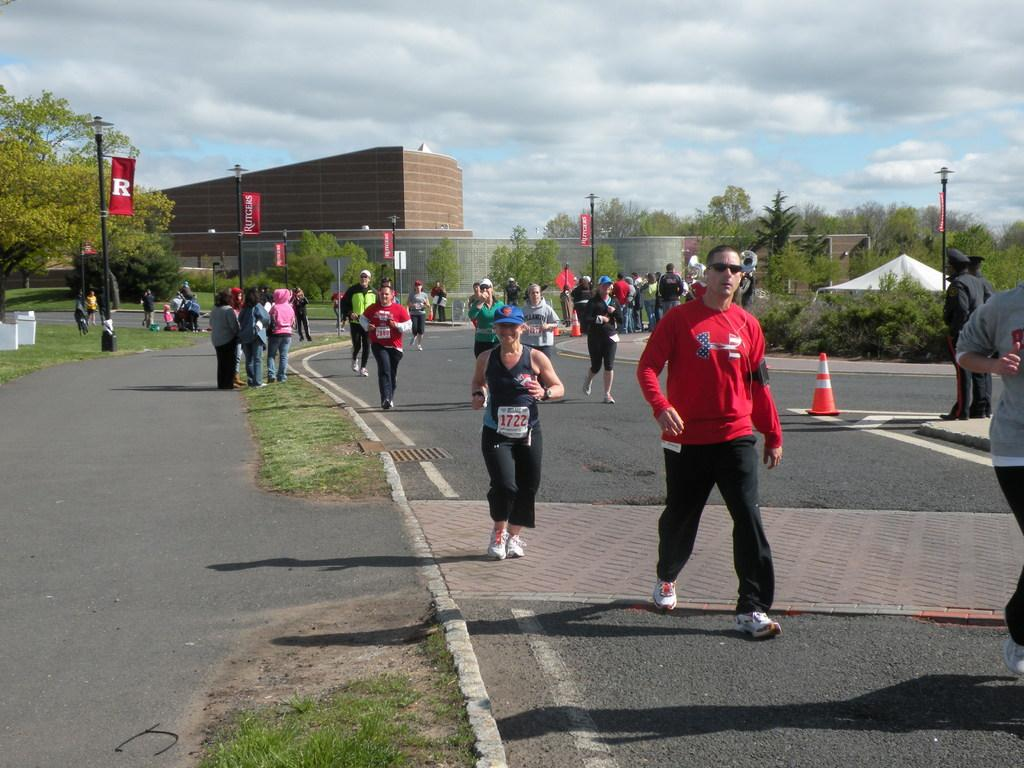How many people are in the image? There are people in the image, but the exact number is not specified. What type of terrain is visible in the image? There is grass in the image, which suggests a natural setting. What object is present in the image that is typically used for traffic control? There is a traffic cone in the image. What architectural features can be seen in the background of the image? The background of the image includes poles and a building. What additional elements are present in the background of the image? The background of the image includes banners and trees. What part of the natural environment is visible in the background of the image? The sky is visible in the background of the image. What type of poison can be seen dripping from the banners in the image? There is no poison present in the image; the banners are not depicted as dripping any substance. Can you spot an owl perched on the traffic cone in the image? There is no owl present in the image; only the people, grass, traffic cone, poles, building, banners, trees, and sky are visible. 